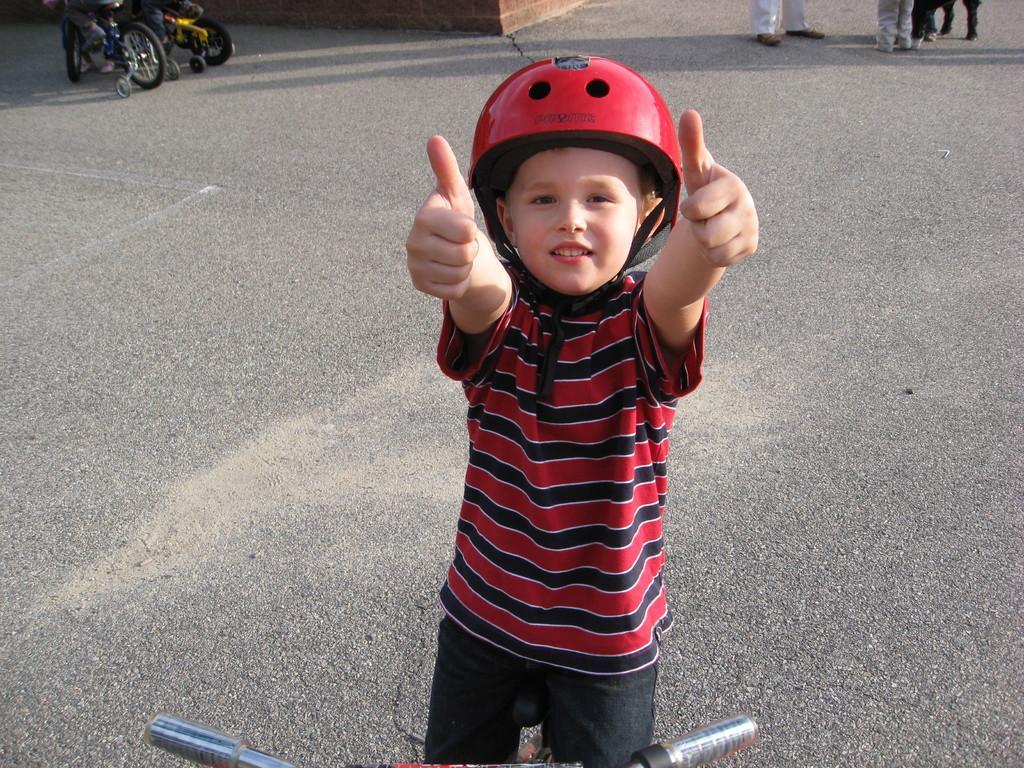Describe this image in one or two sentences. In this image there is a kid wearing red color dress and helmet standing on the road. 